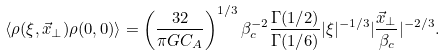<formula> <loc_0><loc_0><loc_500><loc_500>\langle \rho ( \xi , \vec { x } _ { \perp } ) \rho ( 0 , 0 ) \rangle = \left ( \frac { 3 2 } { \pi G C _ { A } } \right ) ^ { 1 / 3 } \beta _ { c } ^ { - 2 } \frac { \Gamma ( 1 / 2 ) } { \Gamma ( 1 / 6 ) } | \xi | ^ { - 1 / 3 } | \frac { \vec { x } _ { \perp } } { \beta _ { c } } | ^ { - 2 / 3 } .</formula> 